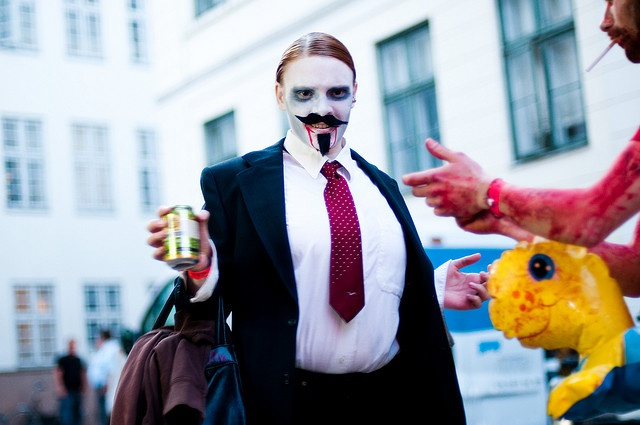Describe the objects in this image and their specific colors. I can see people in lightblue, black, lavender, and purple tones, people in lightblue, brown, lavender, and maroon tones, handbag in lightblue, black, and purple tones, tie in lightblue, purple, and black tones, and handbag in lightblue, black, navy, and blue tones in this image. 